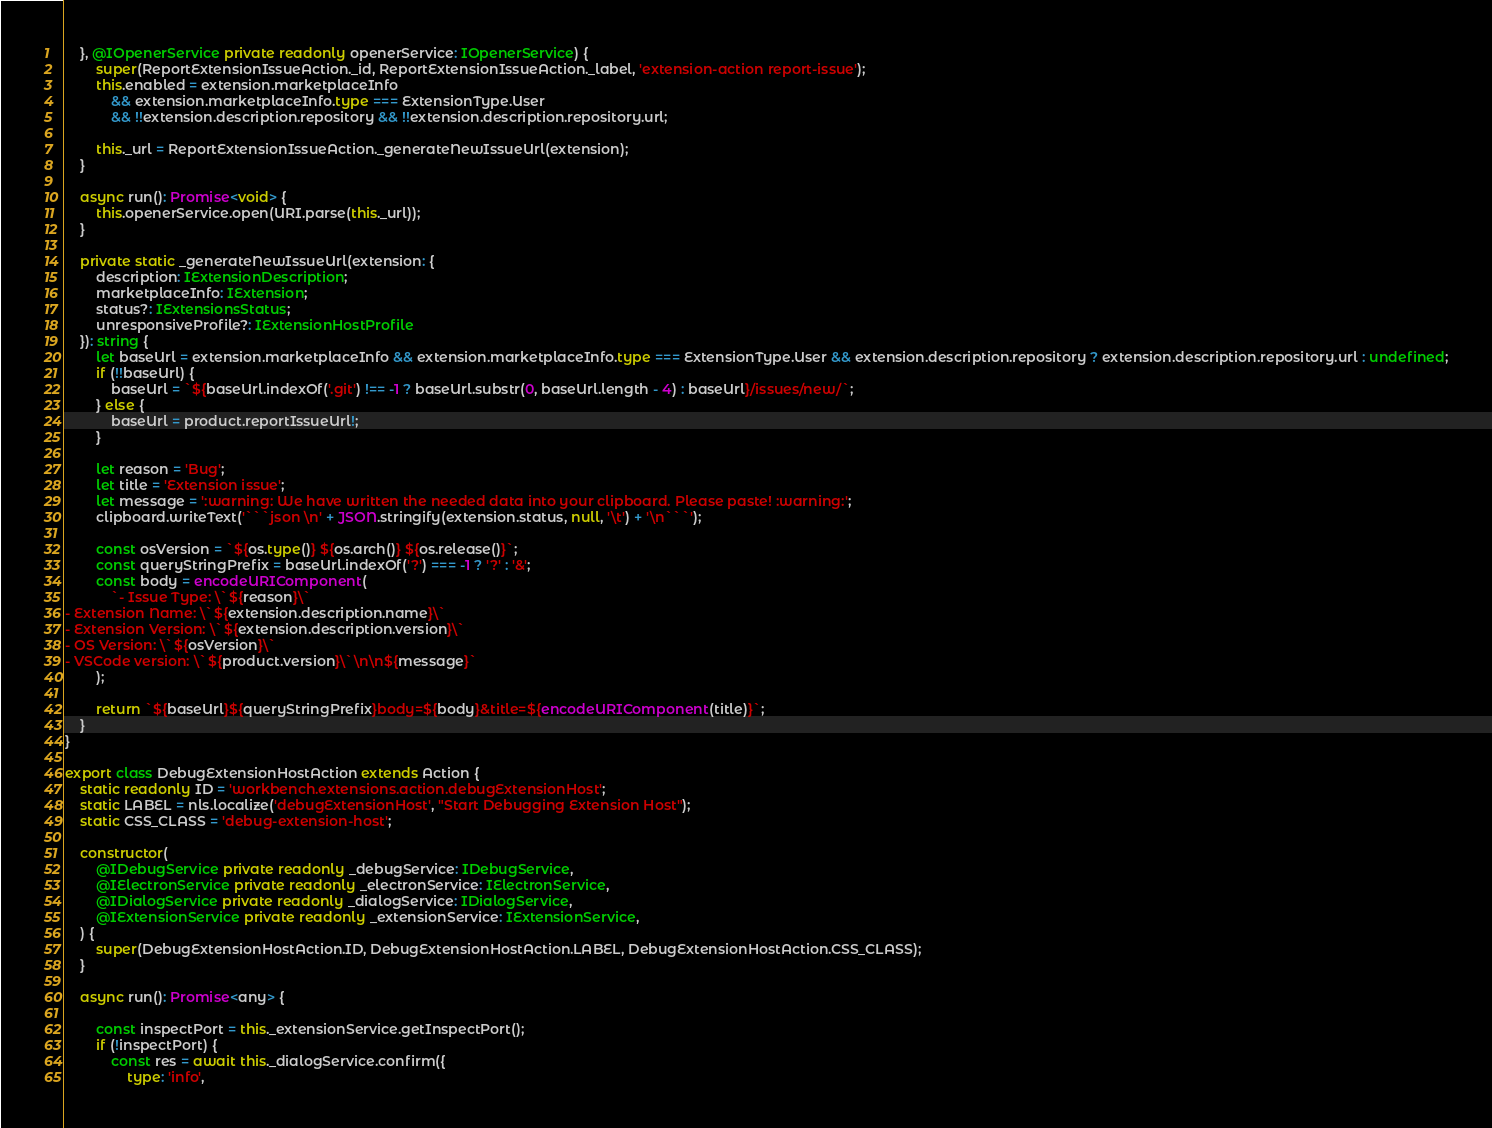<code> <loc_0><loc_0><loc_500><loc_500><_TypeScript_>	}, @IOpenerService private readonly openerService: IOpenerService) {
		super(ReportExtensionIssueAction._id, ReportExtensionIssueAction._label, 'extension-action report-issue');
		this.enabled = extension.marketplaceInfo
			&& extension.marketplaceInfo.type === ExtensionType.User
			&& !!extension.description.repository && !!extension.description.repository.url;

		this._url = ReportExtensionIssueAction._generateNewIssueUrl(extension);
	}

	async run(): Promise<void> {
		this.openerService.open(URI.parse(this._url));
	}

	private static _generateNewIssueUrl(extension: {
		description: IExtensionDescription;
		marketplaceInfo: IExtension;
		status?: IExtensionsStatus;
		unresponsiveProfile?: IExtensionHostProfile
	}): string {
		let baseUrl = extension.marketplaceInfo && extension.marketplaceInfo.type === ExtensionType.User && extension.description.repository ? extension.description.repository.url : undefined;
		if (!!baseUrl) {
			baseUrl = `${baseUrl.indexOf('.git') !== -1 ? baseUrl.substr(0, baseUrl.length - 4) : baseUrl}/issues/new/`;
		} else {
			baseUrl = product.reportIssueUrl!;
		}

		let reason = 'Bug';
		let title = 'Extension issue';
		let message = ':warning: We have written the needed data into your clipboard. Please paste! :warning:';
		clipboard.writeText('```json \n' + JSON.stringify(extension.status, null, '\t') + '\n```');

		const osVersion = `${os.type()} ${os.arch()} ${os.release()}`;
		const queryStringPrefix = baseUrl.indexOf('?') === -1 ? '?' : '&';
		const body = encodeURIComponent(
			`- Issue Type: \`${reason}\`
- Extension Name: \`${extension.description.name}\`
- Extension Version: \`${extension.description.version}\`
- OS Version: \`${osVersion}\`
- VSCode version: \`${product.version}\`\n\n${message}`
		);

		return `${baseUrl}${queryStringPrefix}body=${body}&title=${encodeURIComponent(title)}`;
	}
}

export class DebugExtensionHostAction extends Action {
	static readonly ID = 'workbench.extensions.action.debugExtensionHost';
	static LABEL = nls.localize('debugExtensionHost', "Start Debugging Extension Host");
	static CSS_CLASS = 'debug-extension-host';

	constructor(
		@IDebugService private readonly _debugService: IDebugService,
		@IElectronService private readonly _electronService: IElectronService,
		@IDialogService private readonly _dialogService: IDialogService,
		@IExtensionService private readonly _extensionService: IExtensionService,
	) {
		super(DebugExtensionHostAction.ID, DebugExtensionHostAction.LABEL, DebugExtensionHostAction.CSS_CLASS);
	}

	async run(): Promise<any> {

		const inspectPort = this._extensionService.getInspectPort();
		if (!inspectPort) {
			const res = await this._dialogService.confirm({
				type: 'info',</code> 